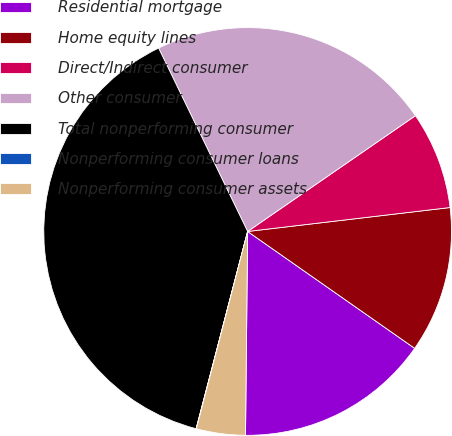Convert chart. <chart><loc_0><loc_0><loc_500><loc_500><pie_chart><fcel>Residential mortgage<fcel>Home equity lines<fcel>Direct/Indirect consumer<fcel>Other consumer<fcel>Total nonperforming consumer<fcel>Nonperforming consumer loans<fcel>Nonperforming consumer assets<nl><fcel>15.45%<fcel>11.59%<fcel>7.74%<fcel>22.58%<fcel>38.74%<fcel>0.02%<fcel>3.88%<nl></chart> 